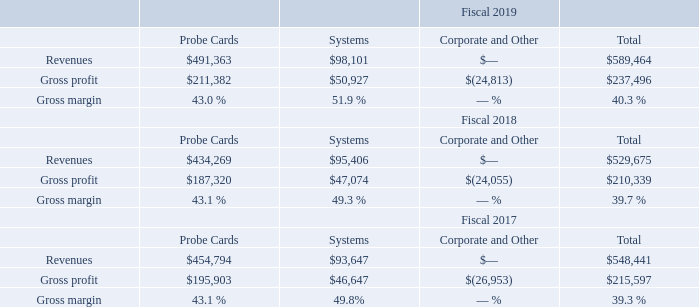Note 15—Segments and Geographic Information
We operate in two reportable segments consisting of the Probe Cards Segment and the Systems Segment. Our chief operating decision maker ("CODM") is our Chief Executive Officer, who reviews operating results to make decisions about allocating resources and assessing performance for the entire company. The following table summarizes the operating results by reportable segment (dollars in thousands):
Operating results provide useful information to our management for assessment of our performance and results of operations. Certain components of our operating results are utilized to determine executive compensation along with other measures.
Corporate and Other includes unallocated expenses relating to amortization of intangible assets, share-based compensation expense, acquisition-related costs, including charges related to inventory stepped up to fair value, and other costs, which are not used in evaluating the results of, or in allocating resources to, our reportable segments. Acquisition-related costs include transaction costs and any costs directly related to the acquisition and integration of acquired businesses.
What does corporate and others include? Includes unallocated expenses relating to amortization of intangible assets, share-based compensation expense, acquisition-related costs, including charges related to inventory stepped up to fair value, and other costs, which are not used in evaluating the results of, or in allocating resources to, our reportable segments. What was the revenues from different segments in 2017? 454,794, 93,647, 0. What are the different streams of revenue? Probe cards, systems, corporate and other. What percentage of total revenue is probe cards revenue in 2017? 454,794 / 548,441
Answer: 0.83. What is the increase / (decrease) in the probe cards revenue from 2018 to 2019? 491,363 - 434,269
Answer: 57094. What is the average revenue in 2017? (454,794 + 93,647 + 0) / 3
Answer: 182813.67. 